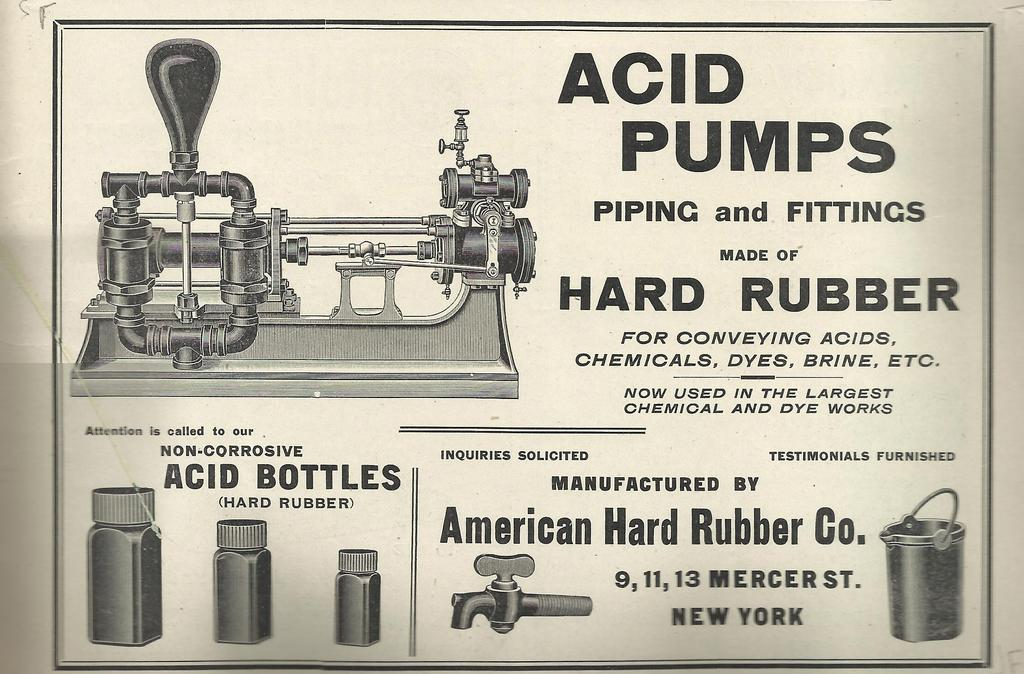Provide a one-sentence caption for the provided image. An advertisement for Acid Pumps that are made out of hard rubber. 